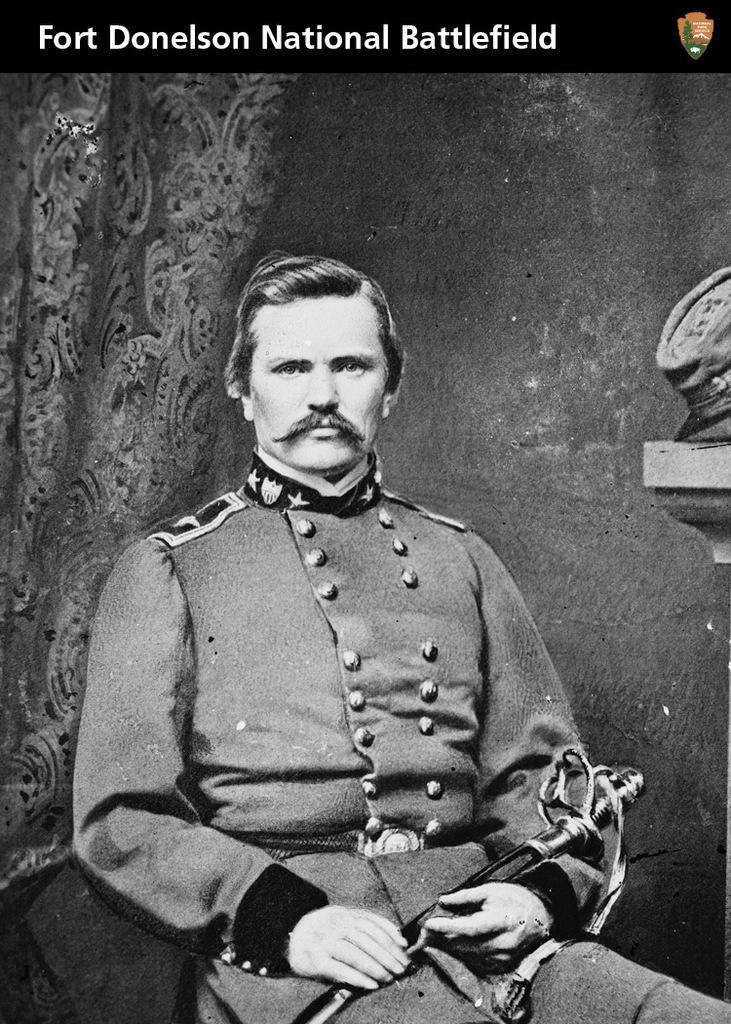Who is present in the image? There is a man in the image. What is the man doing in the image? The man is sitting in the image. What object is the man holding in his hands? The man is holding a knife in his hands. What is the man wearing in the image? The man is wearing a uniform in the image. How many dolls are sitting next to the man in the image? There are no dolls present in the image. What type of fuel is the man using to power his uniform? The man's uniform does not require fuel, and there is no fuel present in the image. 